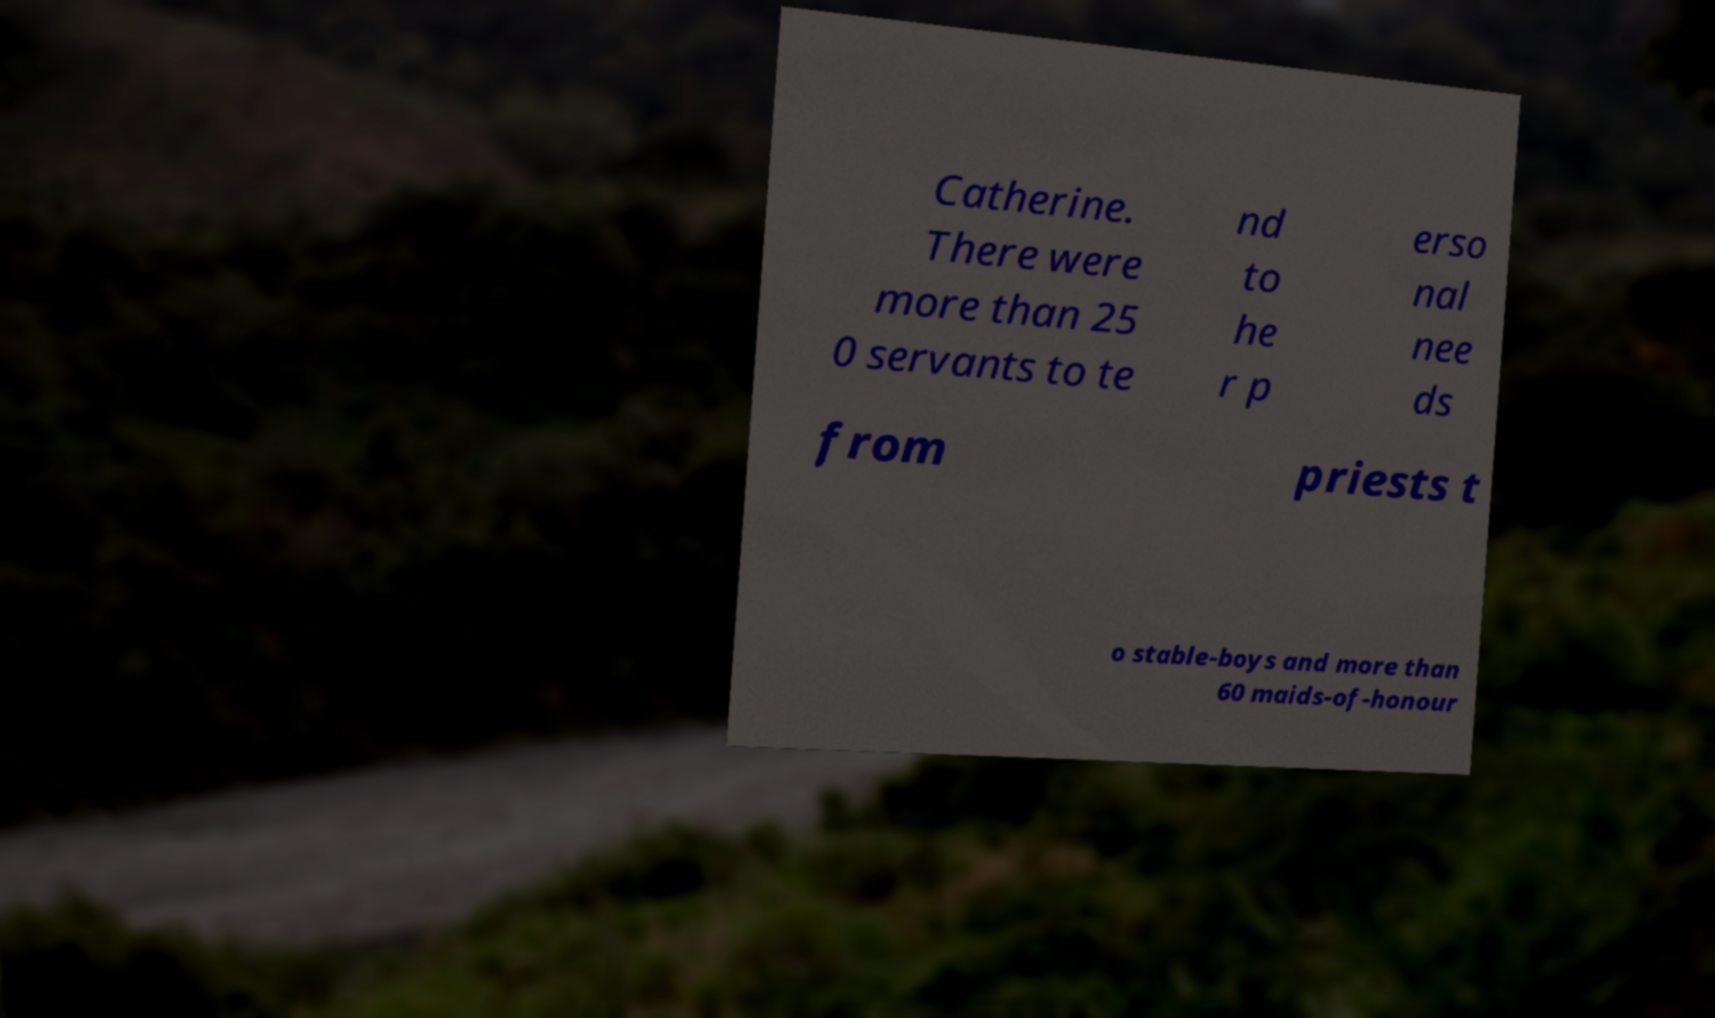Please read and relay the text visible in this image. What does it say? Catherine. There were more than 25 0 servants to te nd to he r p erso nal nee ds from priests t o stable-boys and more than 60 maids-of-honour 